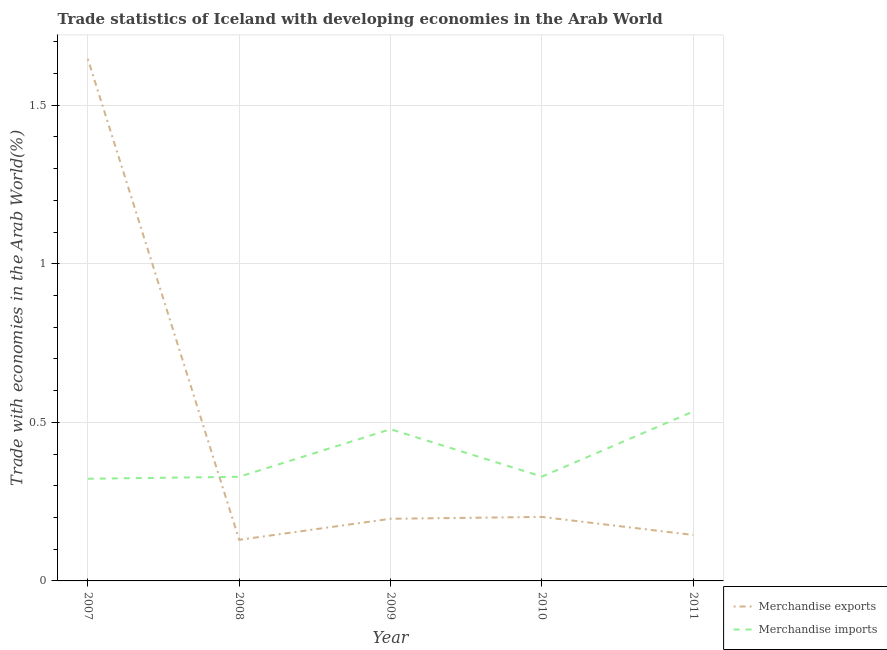How many different coloured lines are there?
Make the answer very short. 2. What is the merchandise exports in 2009?
Your answer should be compact. 0.2. Across all years, what is the maximum merchandise exports?
Your response must be concise. 1.65. Across all years, what is the minimum merchandise imports?
Provide a succinct answer. 0.32. In which year was the merchandise imports minimum?
Offer a very short reply. 2007. What is the total merchandise exports in the graph?
Offer a terse response. 2.32. What is the difference between the merchandise imports in 2008 and that in 2011?
Make the answer very short. -0.21. What is the difference between the merchandise imports in 2007 and the merchandise exports in 2011?
Provide a short and direct response. 0.18. What is the average merchandise imports per year?
Your response must be concise. 0.4. In the year 2008, what is the difference between the merchandise exports and merchandise imports?
Make the answer very short. -0.2. In how many years, is the merchandise exports greater than 1.2 %?
Your answer should be very brief. 1. What is the ratio of the merchandise exports in 2008 to that in 2011?
Provide a succinct answer. 0.89. What is the difference between the highest and the second highest merchandise imports?
Keep it short and to the point. 0.06. What is the difference between the highest and the lowest merchandise exports?
Provide a short and direct response. 1.52. In how many years, is the merchandise exports greater than the average merchandise exports taken over all years?
Your answer should be compact. 1. Does the merchandise exports monotonically increase over the years?
Your answer should be very brief. No. Is the merchandise imports strictly greater than the merchandise exports over the years?
Ensure brevity in your answer.  No. How many lines are there?
Keep it short and to the point. 2. How many years are there in the graph?
Ensure brevity in your answer.  5. What is the difference between two consecutive major ticks on the Y-axis?
Keep it short and to the point. 0.5. Does the graph contain grids?
Give a very brief answer. Yes. Where does the legend appear in the graph?
Give a very brief answer. Bottom right. How many legend labels are there?
Make the answer very short. 2. How are the legend labels stacked?
Your answer should be very brief. Vertical. What is the title of the graph?
Give a very brief answer. Trade statistics of Iceland with developing economies in the Arab World. What is the label or title of the X-axis?
Your response must be concise. Year. What is the label or title of the Y-axis?
Your response must be concise. Trade with economies in the Arab World(%). What is the Trade with economies in the Arab World(%) of Merchandise exports in 2007?
Offer a terse response. 1.65. What is the Trade with economies in the Arab World(%) in Merchandise imports in 2007?
Your answer should be compact. 0.32. What is the Trade with economies in the Arab World(%) in Merchandise exports in 2008?
Keep it short and to the point. 0.13. What is the Trade with economies in the Arab World(%) in Merchandise imports in 2008?
Offer a terse response. 0.33. What is the Trade with economies in the Arab World(%) of Merchandise exports in 2009?
Offer a terse response. 0.2. What is the Trade with economies in the Arab World(%) in Merchandise imports in 2009?
Your answer should be compact. 0.48. What is the Trade with economies in the Arab World(%) of Merchandise exports in 2010?
Provide a succinct answer. 0.2. What is the Trade with economies in the Arab World(%) in Merchandise imports in 2010?
Your answer should be very brief. 0.33. What is the Trade with economies in the Arab World(%) of Merchandise exports in 2011?
Keep it short and to the point. 0.14. What is the Trade with economies in the Arab World(%) of Merchandise imports in 2011?
Keep it short and to the point. 0.53. Across all years, what is the maximum Trade with economies in the Arab World(%) of Merchandise exports?
Keep it short and to the point. 1.65. Across all years, what is the maximum Trade with economies in the Arab World(%) of Merchandise imports?
Offer a terse response. 0.53. Across all years, what is the minimum Trade with economies in the Arab World(%) of Merchandise exports?
Keep it short and to the point. 0.13. Across all years, what is the minimum Trade with economies in the Arab World(%) in Merchandise imports?
Offer a terse response. 0.32. What is the total Trade with economies in the Arab World(%) in Merchandise exports in the graph?
Provide a succinct answer. 2.32. What is the total Trade with economies in the Arab World(%) in Merchandise imports in the graph?
Your answer should be compact. 1.99. What is the difference between the Trade with economies in the Arab World(%) in Merchandise exports in 2007 and that in 2008?
Your answer should be compact. 1.52. What is the difference between the Trade with economies in the Arab World(%) in Merchandise imports in 2007 and that in 2008?
Your answer should be very brief. -0.01. What is the difference between the Trade with economies in the Arab World(%) of Merchandise exports in 2007 and that in 2009?
Ensure brevity in your answer.  1.45. What is the difference between the Trade with economies in the Arab World(%) of Merchandise imports in 2007 and that in 2009?
Provide a short and direct response. -0.16. What is the difference between the Trade with economies in the Arab World(%) of Merchandise exports in 2007 and that in 2010?
Make the answer very short. 1.44. What is the difference between the Trade with economies in the Arab World(%) in Merchandise imports in 2007 and that in 2010?
Offer a terse response. -0.01. What is the difference between the Trade with economies in the Arab World(%) of Merchandise exports in 2007 and that in 2011?
Your answer should be compact. 1.5. What is the difference between the Trade with economies in the Arab World(%) in Merchandise imports in 2007 and that in 2011?
Offer a terse response. -0.21. What is the difference between the Trade with economies in the Arab World(%) in Merchandise exports in 2008 and that in 2009?
Your answer should be compact. -0.07. What is the difference between the Trade with economies in the Arab World(%) of Merchandise exports in 2008 and that in 2010?
Your answer should be compact. -0.07. What is the difference between the Trade with economies in the Arab World(%) in Merchandise imports in 2008 and that in 2010?
Your answer should be very brief. -0. What is the difference between the Trade with economies in the Arab World(%) in Merchandise exports in 2008 and that in 2011?
Your answer should be compact. -0.02. What is the difference between the Trade with economies in the Arab World(%) of Merchandise imports in 2008 and that in 2011?
Ensure brevity in your answer.  -0.21. What is the difference between the Trade with economies in the Arab World(%) of Merchandise exports in 2009 and that in 2010?
Your response must be concise. -0.01. What is the difference between the Trade with economies in the Arab World(%) in Merchandise imports in 2009 and that in 2010?
Your response must be concise. 0.15. What is the difference between the Trade with economies in the Arab World(%) in Merchandise exports in 2009 and that in 2011?
Ensure brevity in your answer.  0.05. What is the difference between the Trade with economies in the Arab World(%) of Merchandise imports in 2009 and that in 2011?
Your response must be concise. -0.06. What is the difference between the Trade with economies in the Arab World(%) in Merchandise exports in 2010 and that in 2011?
Keep it short and to the point. 0.06. What is the difference between the Trade with economies in the Arab World(%) in Merchandise imports in 2010 and that in 2011?
Make the answer very short. -0.21. What is the difference between the Trade with economies in the Arab World(%) in Merchandise exports in 2007 and the Trade with economies in the Arab World(%) in Merchandise imports in 2008?
Make the answer very short. 1.32. What is the difference between the Trade with economies in the Arab World(%) in Merchandise exports in 2007 and the Trade with economies in the Arab World(%) in Merchandise imports in 2009?
Offer a terse response. 1.17. What is the difference between the Trade with economies in the Arab World(%) in Merchandise exports in 2007 and the Trade with economies in the Arab World(%) in Merchandise imports in 2010?
Ensure brevity in your answer.  1.32. What is the difference between the Trade with economies in the Arab World(%) in Merchandise exports in 2007 and the Trade with economies in the Arab World(%) in Merchandise imports in 2011?
Your answer should be very brief. 1.11. What is the difference between the Trade with economies in the Arab World(%) in Merchandise exports in 2008 and the Trade with economies in the Arab World(%) in Merchandise imports in 2009?
Your response must be concise. -0.35. What is the difference between the Trade with economies in the Arab World(%) in Merchandise exports in 2008 and the Trade with economies in the Arab World(%) in Merchandise imports in 2010?
Make the answer very short. -0.2. What is the difference between the Trade with economies in the Arab World(%) in Merchandise exports in 2008 and the Trade with economies in the Arab World(%) in Merchandise imports in 2011?
Ensure brevity in your answer.  -0.4. What is the difference between the Trade with economies in the Arab World(%) of Merchandise exports in 2009 and the Trade with economies in the Arab World(%) of Merchandise imports in 2010?
Your response must be concise. -0.13. What is the difference between the Trade with economies in the Arab World(%) of Merchandise exports in 2009 and the Trade with economies in the Arab World(%) of Merchandise imports in 2011?
Provide a short and direct response. -0.34. What is the difference between the Trade with economies in the Arab World(%) of Merchandise exports in 2010 and the Trade with economies in the Arab World(%) of Merchandise imports in 2011?
Provide a short and direct response. -0.33. What is the average Trade with economies in the Arab World(%) in Merchandise exports per year?
Provide a succinct answer. 0.46. What is the average Trade with economies in the Arab World(%) of Merchandise imports per year?
Provide a succinct answer. 0.4. In the year 2007, what is the difference between the Trade with economies in the Arab World(%) in Merchandise exports and Trade with economies in the Arab World(%) in Merchandise imports?
Your answer should be very brief. 1.32. In the year 2008, what is the difference between the Trade with economies in the Arab World(%) in Merchandise exports and Trade with economies in the Arab World(%) in Merchandise imports?
Provide a succinct answer. -0.2. In the year 2009, what is the difference between the Trade with economies in the Arab World(%) of Merchandise exports and Trade with economies in the Arab World(%) of Merchandise imports?
Your answer should be compact. -0.28. In the year 2010, what is the difference between the Trade with economies in the Arab World(%) in Merchandise exports and Trade with economies in the Arab World(%) in Merchandise imports?
Your answer should be compact. -0.13. In the year 2011, what is the difference between the Trade with economies in the Arab World(%) in Merchandise exports and Trade with economies in the Arab World(%) in Merchandise imports?
Provide a succinct answer. -0.39. What is the ratio of the Trade with economies in the Arab World(%) of Merchandise exports in 2007 to that in 2008?
Give a very brief answer. 12.7. What is the ratio of the Trade with economies in the Arab World(%) of Merchandise imports in 2007 to that in 2008?
Offer a terse response. 0.98. What is the ratio of the Trade with economies in the Arab World(%) in Merchandise exports in 2007 to that in 2009?
Your answer should be compact. 8.4. What is the ratio of the Trade with economies in the Arab World(%) in Merchandise imports in 2007 to that in 2009?
Offer a very short reply. 0.67. What is the ratio of the Trade with economies in the Arab World(%) of Merchandise exports in 2007 to that in 2010?
Your response must be concise. 8.16. What is the ratio of the Trade with economies in the Arab World(%) of Merchandise imports in 2007 to that in 2010?
Offer a terse response. 0.98. What is the ratio of the Trade with economies in the Arab World(%) in Merchandise exports in 2007 to that in 2011?
Your answer should be very brief. 11.36. What is the ratio of the Trade with economies in the Arab World(%) in Merchandise imports in 2007 to that in 2011?
Offer a terse response. 0.6. What is the ratio of the Trade with economies in the Arab World(%) in Merchandise exports in 2008 to that in 2009?
Offer a terse response. 0.66. What is the ratio of the Trade with economies in the Arab World(%) in Merchandise imports in 2008 to that in 2009?
Give a very brief answer. 0.69. What is the ratio of the Trade with economies in the Arab World(%) of Merchandise exports in 2008 to that in 2010?
Your response must be concise. 0.64. What is the ratio of the Trade with economies in the Arab World(%) of Merchandise exports in 2008 to that in 2011?
Provide a short and direct response. 0.89. What is the ratio of the Trade with economies in the Arab World(%) in Merchandise imports in 2008 to that in 2011?
Provide a short and direct response. 0.61. What is the ratio of the Trade with economies in the Arab World(%) in Merchandise exports in 2009 to that in 2010?
Provide a short and direct response. 0.97. What is the ratio of the Trade with economies in the Arab World(%) in Merchandise imports in 2009 to that in 2010?
Offer a very short reply. 1.45. What is the ratio of the Trade with economies in the Arab World(%) of Merchandise exports in 2009 to that in 2011?
Offer a very short reply. 1.35. What is the ratio of the Trade with economies in the Arab World(%) of Merchandise imports in 2009 to that in 2011?
Give a very brief answer. 0.9. What is the ratio of the Trade with economies in the Arab World(%) in Merchandise exports in 2010 to that in 2011?
Your response must be concise. 1.39. What is the ratio of the Trade with economies in the Arab World(%) in Merchandise imports in 2010 to that in 2011?
Offer a very short reply. 0.62. What is the difference between the highest and the second highest Trade with economies in the Arab World(%) of Merchandise exports?
Provide a short and direct response. 1.44. What is the difference between the highest and the second highest Trade with economies in the Arab World(%) in Merchandise imports?
Offer a terse response. 0.06. What is the difference between the highest and the lowest Trade with economies in the Arab World(%) in Merchandise exports?
Provide a succinct answer. 1.52. What is the difference between the highest and the lowest Trade with economies in the Arab World(%) of Merchandise imports?
Ensure brevity in your answer.  0.21. 